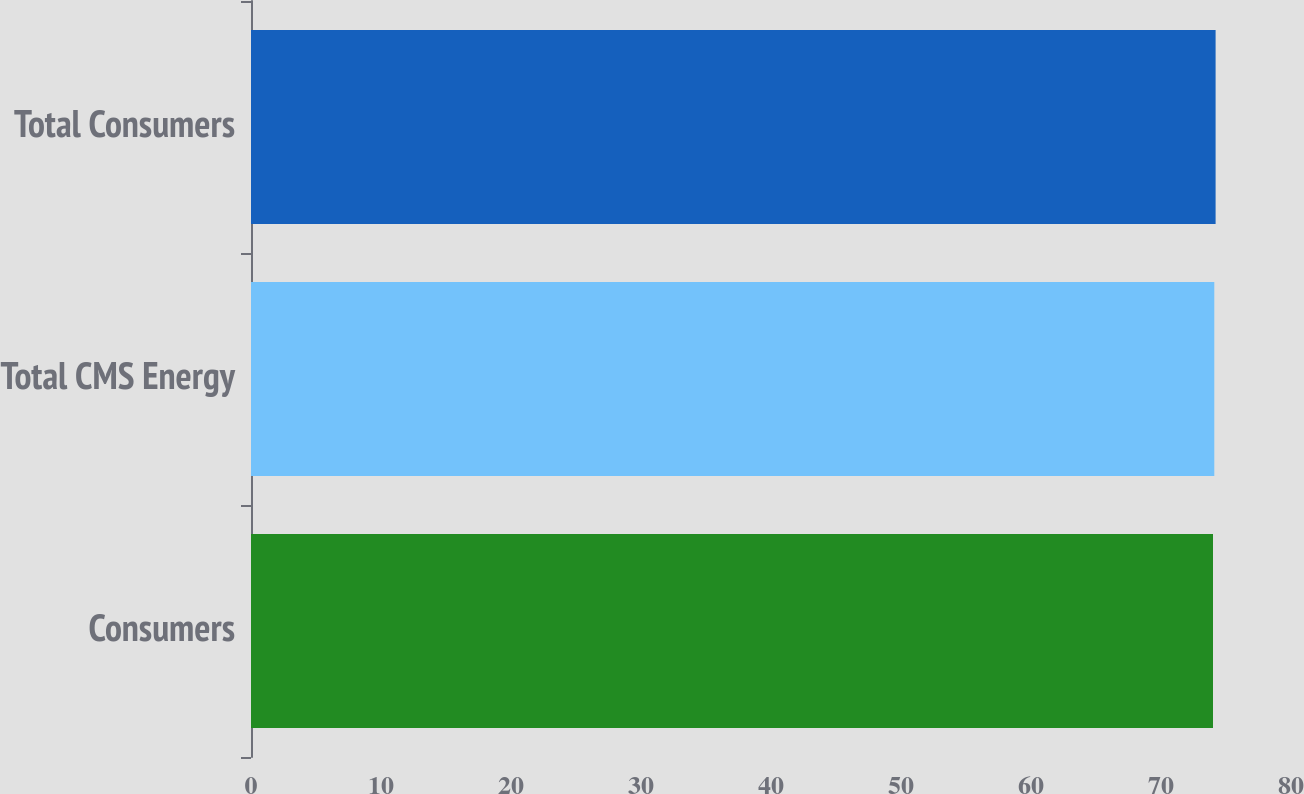<chart> <loc_0><loc_0><loc_500><loc_500><bar_chart><fcel>Consumers<fcel>Total CMS Energy<fcel>Total Consumers<nl><fcel>74<fcel>74.1<fcel>74.2<nl></chart> 